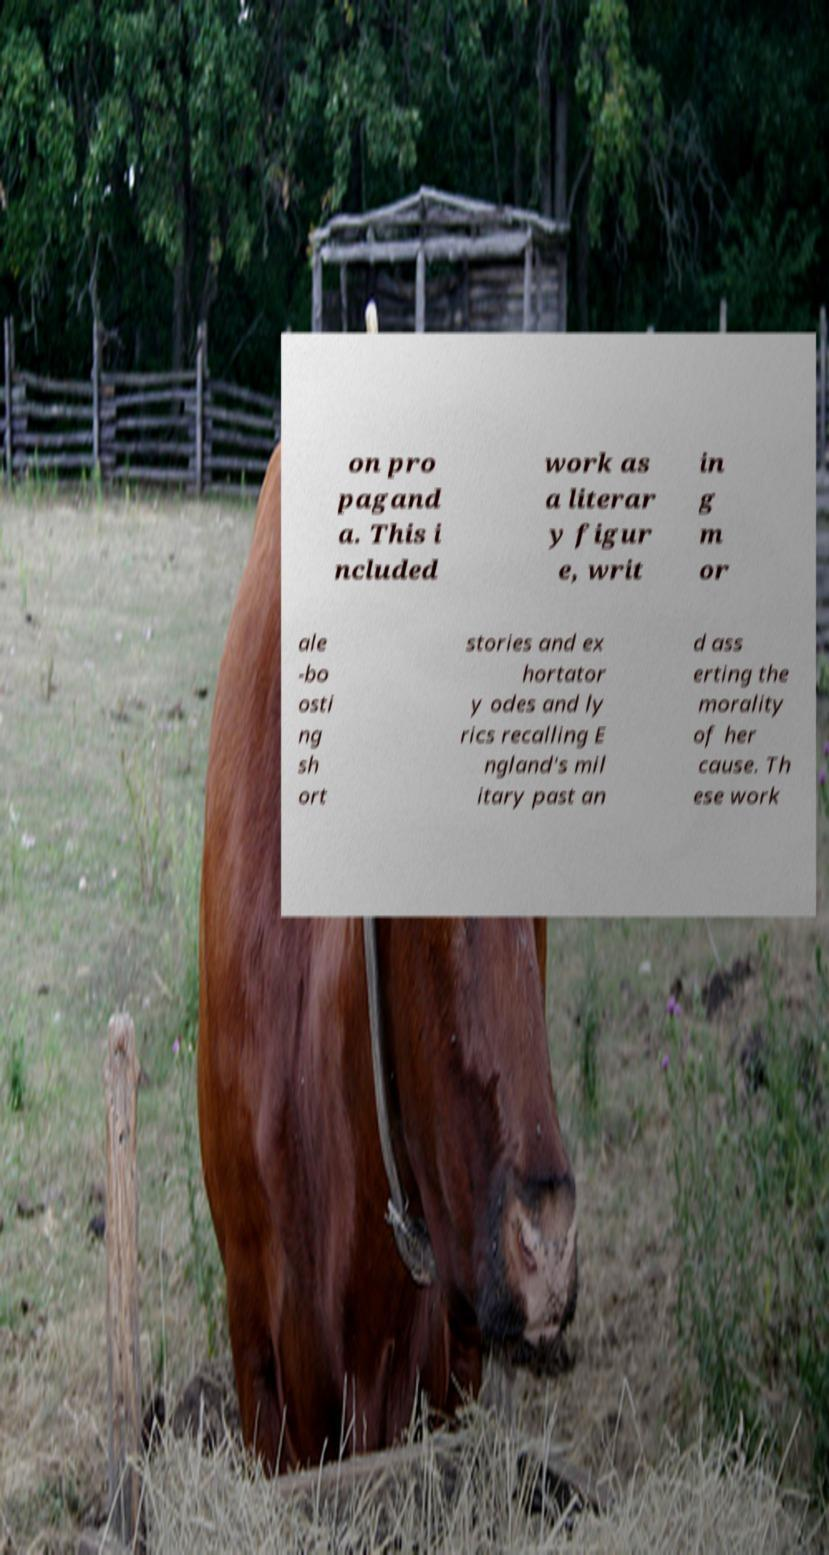Could you assist in decoding the text presented in this image and type it out clearly? on pro pagand a. This i ncluded work as a literar y figur e, writ in g m or ale -bo osti ng sh ort stories and ex hortator y odes and ly rics recalling E ngland's mil itary past an d ass erting the morality of her cause. Th ese work 